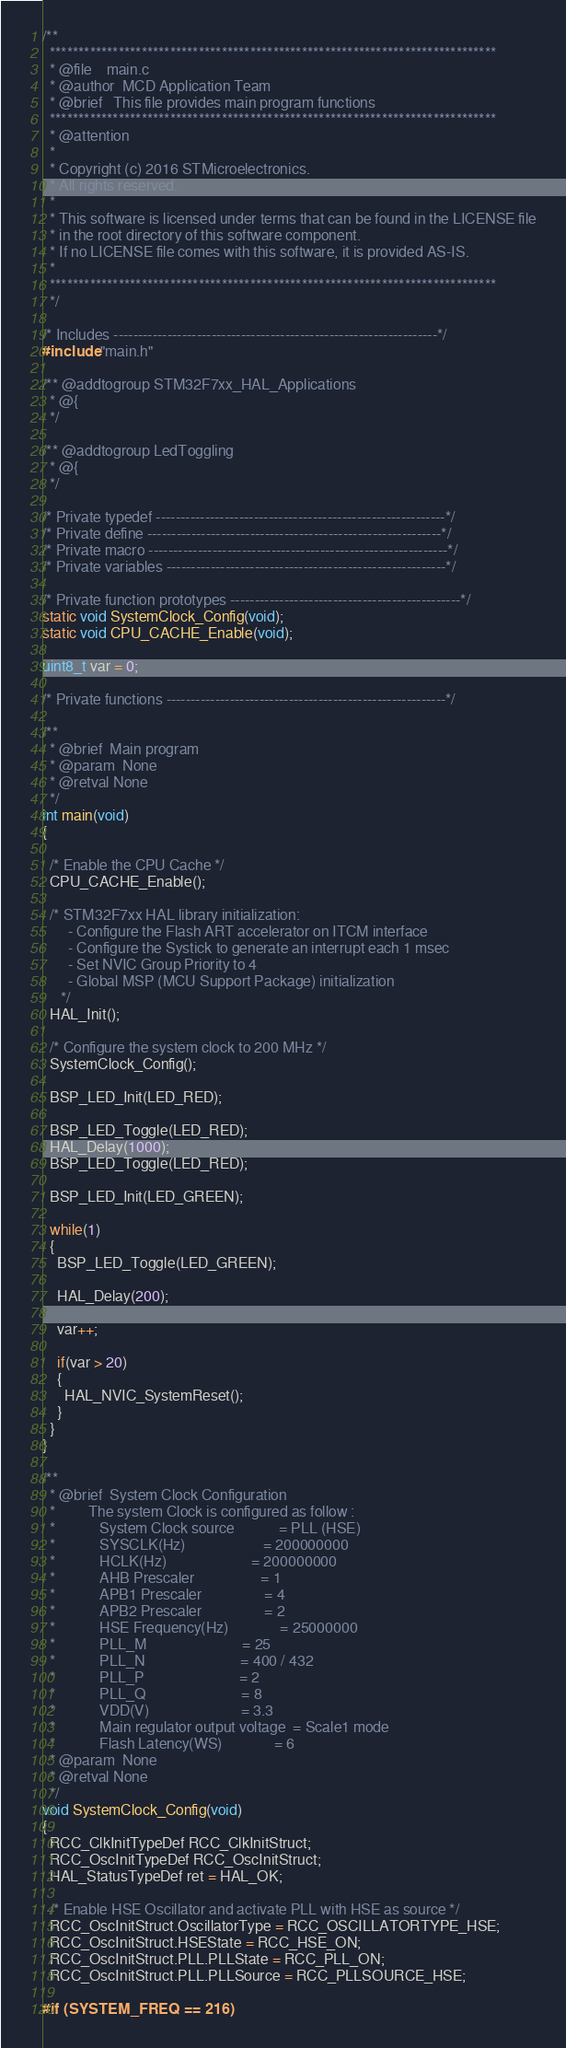Convert code to text. <code><loc_0><loc_0><loc_500><loc_500><_C_>/**
  ******************************************************************************
  * @file    main.c
  * @author  MCD Application Team
  * @brief   This file provides main program functions
  ******************************************************************************
  * @attention
  *
  * Copyright (c) 2016 STMicroelectronics.
  * All rights reserved.
  *
  * This software is licensed under terms that can be found in the LICENSE file
  * in the root directory of this software component.
  * If no LICENSE file comes with this software, it is provided AS-IS.
  *
  ******************************************************************************
  */

/* Includes ------------------------------------------------------------------*/
#include "main.h"

/** @addtogroup STM32F7xx_HAL_Applications
  * @{
  */

/** @addtogroup LedToggling
  * @{
  */

/* Private typedef -----------------------------------------------------------*/
/* Private define ------------------------------------------------------------*/
/* Private macro -------------------------------------------------------------*/
/* Private variables ---------------------------------------------------------*/

/* Private function prototypes -----------------------------------------------*/
static void SystemClock_Config(void);
static void CPU_CACHE_Enable(void);

uint8_t var = 0;

/* Private functions ---------------------------------------------------------*/

/**
  * @brief  Main program
  * @param  None
  * @retval None
  */
int main(void)
{

  /* Enable the CPU Cache */
  CPU_CACHE_Enable();

  /* STM32F7xx HAL library initialization:
       - Configure the Flash ART accelerator on ITCM interface
       - Configure the Systick to generate an interrupt each 1 msec
       - Set NVIC Group Priority to 4
       - Global MSP (MCU Support Package) initialization
     */
  HAL_Init();

  /* Configure the system clock to 200 MHz */
  SystemClock_Config();

  BSP_LED_Init(LED_RED);

  BSP_LED_Toggle(LED_RED);
  HAL_Delay(1000);
  BSP_LED_Toggle(LED_RED);

  BSP_LED_Init(LED_GREEN);

  while(1)
  {
    BSP_LED_Toggle(LED_GREEN);

    HAL_Delay(200);

    var++;

    if(var > 20)
    {
      HAL_NVIC_SystemReset();
    }
  }
}

/**
  * @brief  System Clock Configuration
  *         The system Clock is configured as follow : 
  *            System Clock source            = PLL (HSE)
  *            SYSCLK(Hz)                     = 200000000
  *            HCLK(Hz)                       = 200000000
  *            AHB Prescaler                  = 1
  *            APB1 Prescaler                 = 4
  *            APB2 Prescaler                 = 2
  *            HSE Frequency(Hz)              = 25000000
  *            PLL_M                          = 25
  *            PLL_N                          = 400 / 432
  *            PLL_P                          = 2
  *            PLL_Q                          = 8
  *            VDD(V)                         = 3.3
  *            Main regulator output voltage  = Scale1 mode
  *            Flash Latency(WS)              = 6
  * @param  None
  * @retval None
  */
void SystemClock_Config(void)
{
  RCC_ClkInitTypeDef RCC_ClkInitStruct;
  RCC_OscInitTypeDef RCC_OscInitStruct;
  HAL_StatusTypeDef ret = HAL_OK;

  /* Enable HSE Oscillator and activate PLL with HSE as source */
  RCC_OscInitStruct.OscillatorType = RCC_OSCILLATORTYPE_HSE;
  RCC_OscInitStruct.HSEState = RCC_HSE_ON;
  RCC_OscInitStruct.PLL.PLLState = RCC_PLL_ON;
  RCC_OscInitStruct.PLL.PLLSource = RCC_PLLSOURCE_HSE;

#if (SYSTEM_FREQ == 216)</code> 